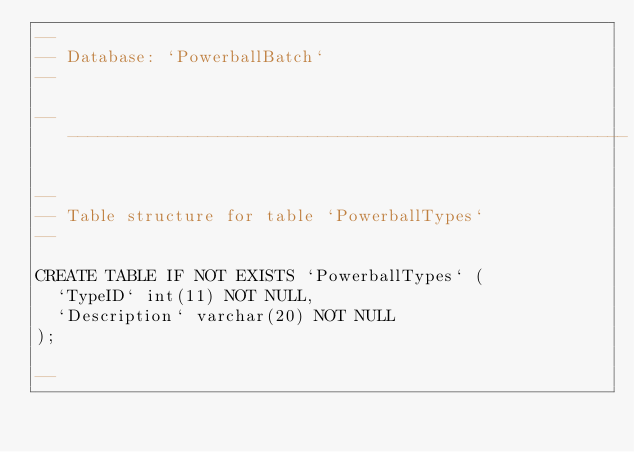Convert code to text. <code><loc_0><loc_0><loc_500><loc_500><_SQL_>--
-- Database: `PowerballBatch`
--

-- --------------------------------------------------------

--
-- Table structure for table `PowerballTypes`
--

CREATE TABLE IF NOT EXISTS `PowerballTypes` (
  `TypeID` int(11) NOT NULL,
  `Description` varchar(20) NOT NULL
);

--</code> 